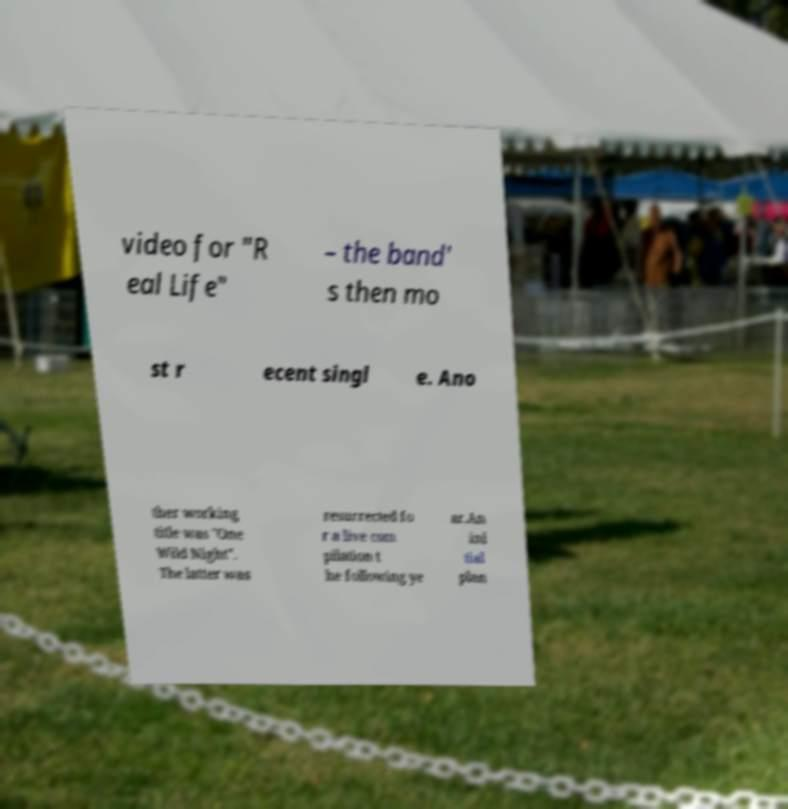Can you accurately transcribe the text from the provided image for me? video for "R eal Life" – the band' s then mo st r ecent singl e. Ano ther working title was "One Wild Night". The latter was resurrected fo r a live com pilation t he following ye ar.An ini tial plan 